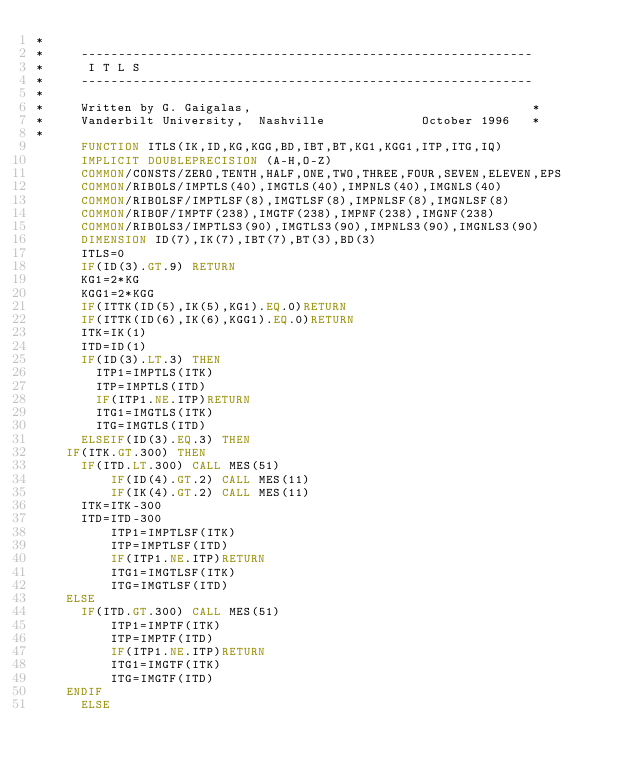Convert code to text. <code><loc_0><loc_0><loc_500><loc_500><_FORTRAN_>*
*     -------------------------------------------------------------
*      I T L S
*     -------------------------------------------------------------
*
*     Written by G. Gaigalas,                                      * 
*     Vanderbilt University,  Nashville             October 1996   * 
*
      FUNCTION ITLS(IK,ID,KG,KGG,BD,IBT,BT,KG1,KGG1,ITP,ITG,IQ)
      IMPLICIT DOUBLEPRECISION (A-H,O-Z)
      COMMON/CONSTS/ZERO,TENTH,HALF,ONE,TWO,THREE,FOUR,SEVEN,ELEVEN,EPS
      COMMON/RIBOLS/IMPTLS(40),IMGTLS(40),IMPNLS(40),IMGNLS(40)
      COMMON/RIBOLSF/IMPTLSF(8),IMGTLSF(8),IMPNLSF(8),IMGNLSF(8)
      COMMON/RIBOF/IMPTF(238),IMGTF(238),IMPNF(238),IMGNF(238)
      COMMON/RIBOLS3/IMPTLS3(90),IMGTLS3(90),IMPNLS3(90),IMGNLS3(90)
      DIMENSION ID(7),IK(7),IBT(7),BT(3),BD(3)
      ITLS=0
      IF(ID(3).GT.9) RETURN
      KG1=2*KG
      KGG1=2*KGG
      IF(ITTK(ID(5),IK(5),KG1).EQ.0)RETURN
      IF(ITTK(ID(6),IK(6),KGG1).EQ.0)RETURN
      ITK=IK(1)
      ITD=ID(1)
      IF(ID(3).LT.3) THEN
        ITP1=IMPTLS(ITK)
        ITP=IMPTLS(ITD)
        IF(ITP1.NE.ITP)RETURN
        ITG1=IMGTLS(ITK)
        ITG=IMGTLS(ITD)
      ELSEIF(ID(3).EQ.3) THEN
	IF(ITK.GT.300) THEN
	  IF(ITD.LT.300) CALL MES(51)
          IF(ID(4).GT.2) CALL MES(11)
          IF(IK(4).GT.2) CALL MES(11)
	  ITK=ITK-300
	  ITD=ITD-300
          ITP1=IMPTLSF(ITK)
          ITP=IMPTLSF(ITD)
          IF(ITP1.NE.ITP)RETURN
          ITG1=IMGTLSF(ITK)
          ITG=IMGTLSF(ITD)
	ELSE
	  IF(ITD.GT.300) CALL MES(51)
          ITP1=IMPTF(ITK)
          ITP=IMPTF(ITD)
          IF(ITP1.NE.ITP)RETURN
          ITG1=IMGTF(ITK)
          ITG=IMGTF(ITD)
	ENDIF
      ELSE</code> 